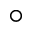Convert formula to latex. <formula><loc_0><loc_0><loc_500><loc_500>\circ</formula> 